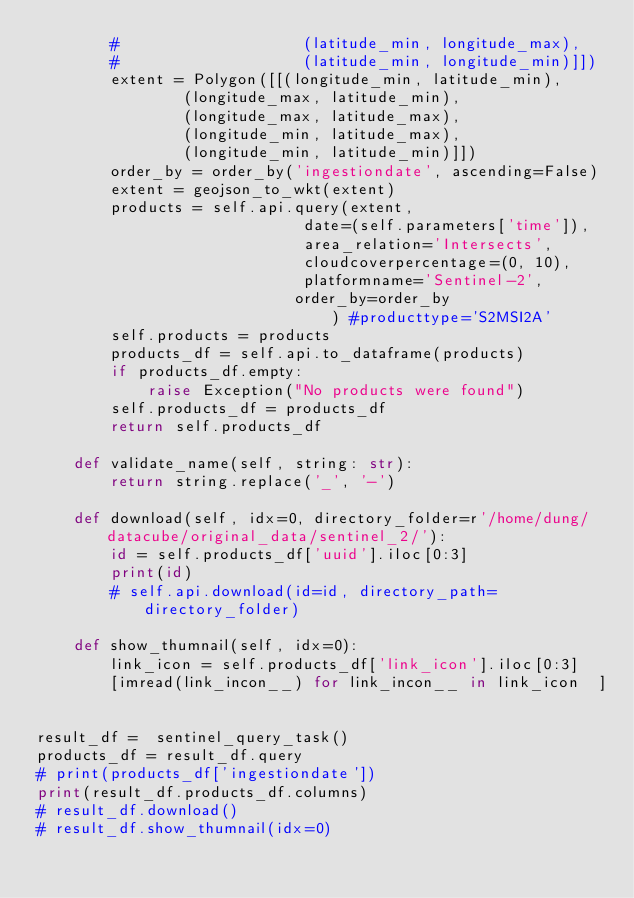<code> <loc_0><loc_0><loc_500><loc_500><_Python_>        #                    (latitude_min, longitude_max),
        #                    (latitude_min, longitude_min)]])
        extent = Polygon([[(longitude_min, latitude_min),
                (longitude_max, latitude_min),
                (longitude_max, latitude_max),
                (longitude_min, latitude_max),
                (longitude_min, latitude_min)]])
        order_by = order_by('ingestiondate', ascending=False)
        extent = geojson_to_wkt(extent)
        products = self.api.query(extent,
                             date=(self.parameters['time']),
                             area_relation='Intersects',
                             cloudcoverpercentage=(0, 10),
                             platformname='Sentinel-2',
                            order_by=order_by
                                ) #producttype='S2MSI2A'
        self.products = products
        products_df = self.api.to_dataframe(products)
        if products_df.empty:
            raise Exception("No products were found")
        self.products_df = products_df
        return self.products_df

    def validate_name(self, string: str):
        return string.replace('_', '-')

    def download(self, idx=0, directory_folder=r'/home/dung/datacube/original_data/sentinel_2/'):
        id = self.products_df['uuid'].iloc[0:3]
        print(id)
        # self.api.download(id=id, directory_path=directory_folder)

    def show_thumnail(self, idx=0):
        link_icon = self.products_df['link_icon'].iloc[0:3]
        [imread(link_incon__) for link_incon__ in link_icon  ]


result_df =  sentinel_query_task()
products_df = result_df.query
# print(products_df['ingestiondate'])
print(result_df.products_df.columns)
# result_df.download()
# result_df.show_thumnail(idx=0)
</code> 